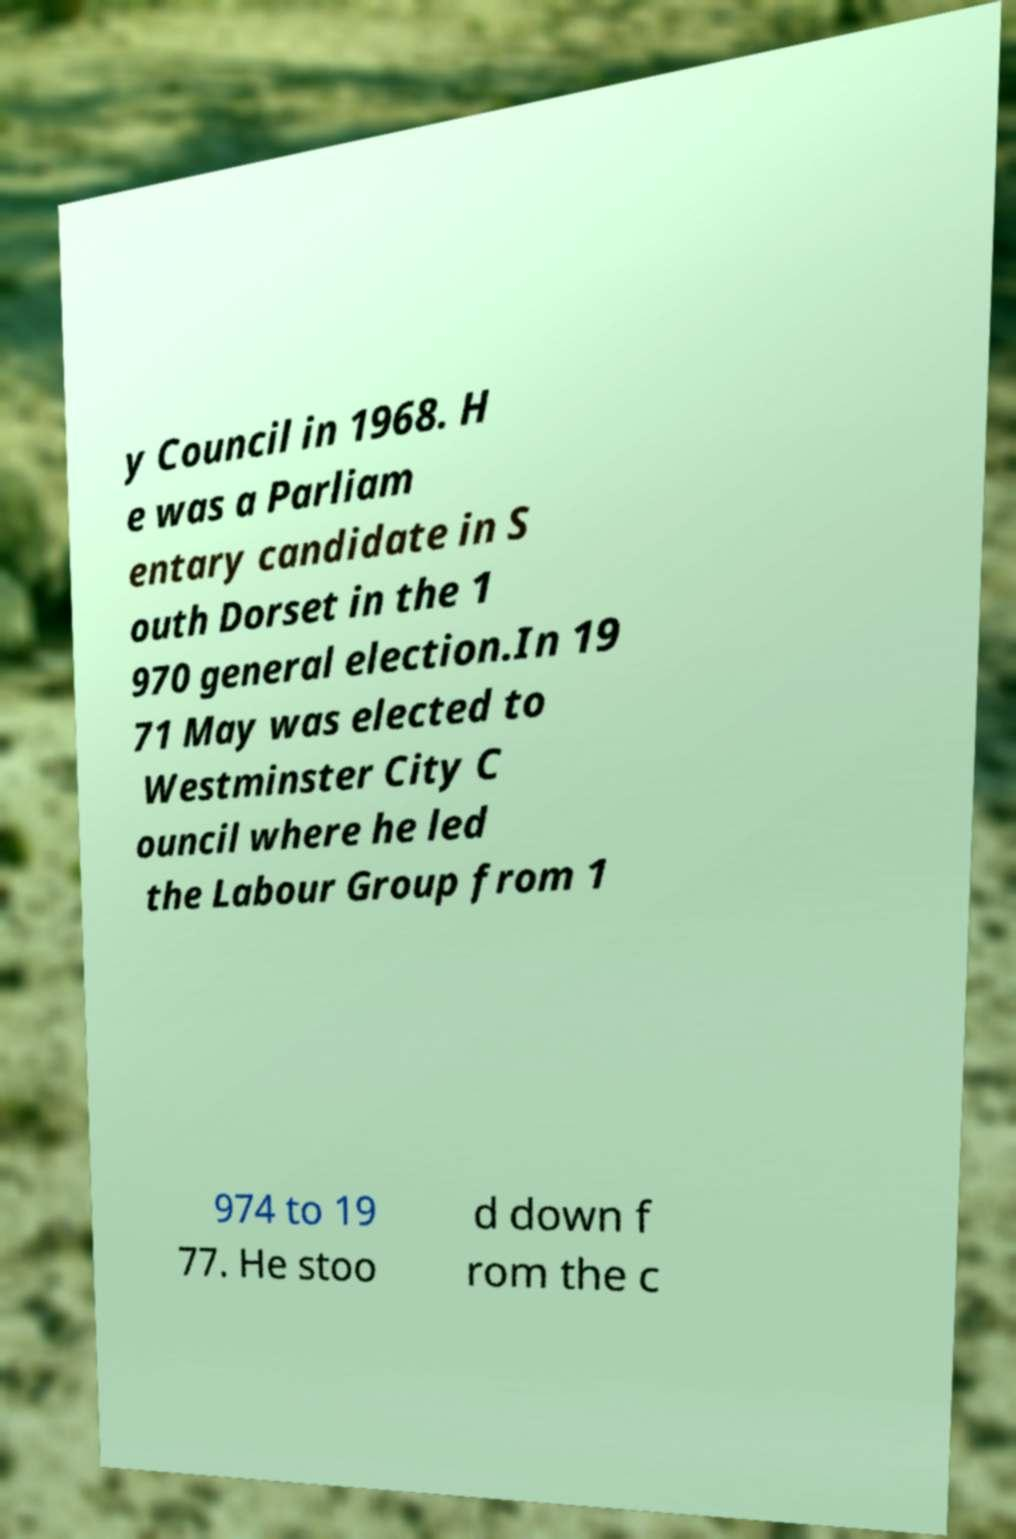Could you assist in decoding the text presented in this image and type it out clearly? y Council in 1968. H e was a Parliam entary candidate in S outh Dorset in the 1 970 general election.In 19 71 May was elected to Westminster City C ouncil where he led the Labour Group from 1 974 to 19 77. He stoo d down f rom the c 